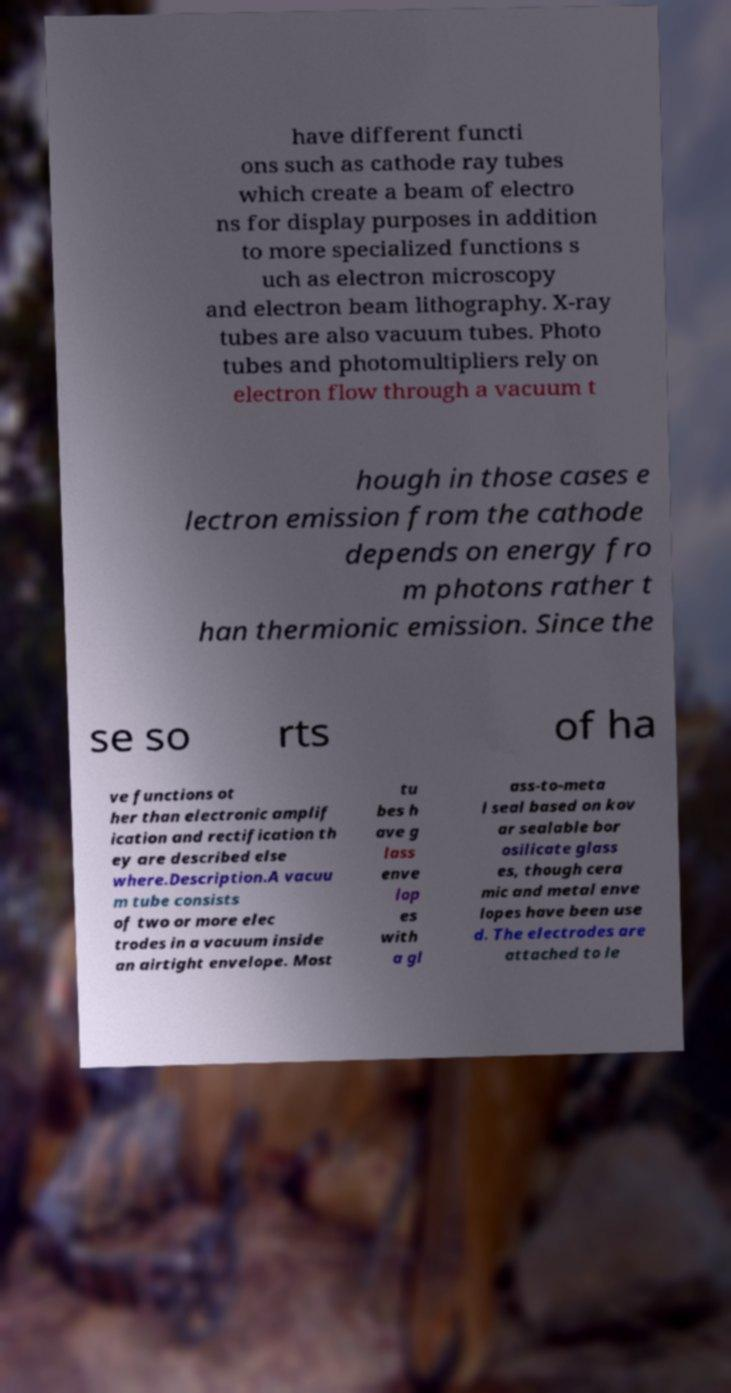There's text embedded in this image that I need extracted. Can you transcribe it verbatim? have different functi ons such as cathode ray tubes which create a beam of electro ns for display purposes in addition to more specialized functions s uch as electron microscopy and electron beam lithography. X-ray tubes are also vacuum tubes. Photo tubes and photomultipliers rely on electron flow through a vacuum t hough in those cases e lectron emission from the cathode depends on energy fro m photons rather t han thermionic emission. Since the se so rts of ha ve functions ot her than electronic amplif ication and rectification th ey are described else where.Description.A vacuu m tube consists of two or more elec trodes in a vacuum inside an airtight envelope. Most tu bes h ave g lass enve lop es with a gl ass-to-meta l seal based on kov ar sealable bor osilicate glass es, though cera mic and metal enve lopes have been use d. The electrodes are attached to le 